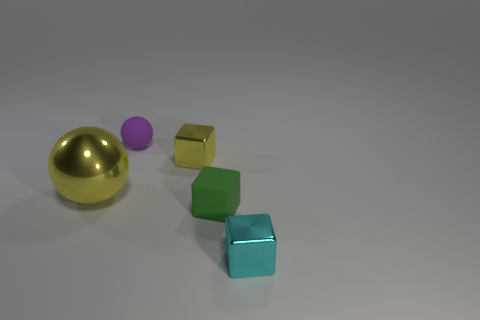Add 2 small yellow things. How many objects exist? 7 Subtract all yellow balls. How many balls are left? 1 Subtract all shiny blocks. How many blocks are left? 1 Subtract 3 blocks. How many blocks are left? 0 Subtract all blocks. How many objects are left? 2 Subtract all brown spheres. How many gray blocks are left? 0 Subtract all purple balls. Subtract all tiny things. How many objects are left? 0 Add 2 big things. How many big things are left? 3 Add 5 yellow balls. How many yellow balls exist? 6 Subtract 0 purple cubes. How many objects are left? 5 